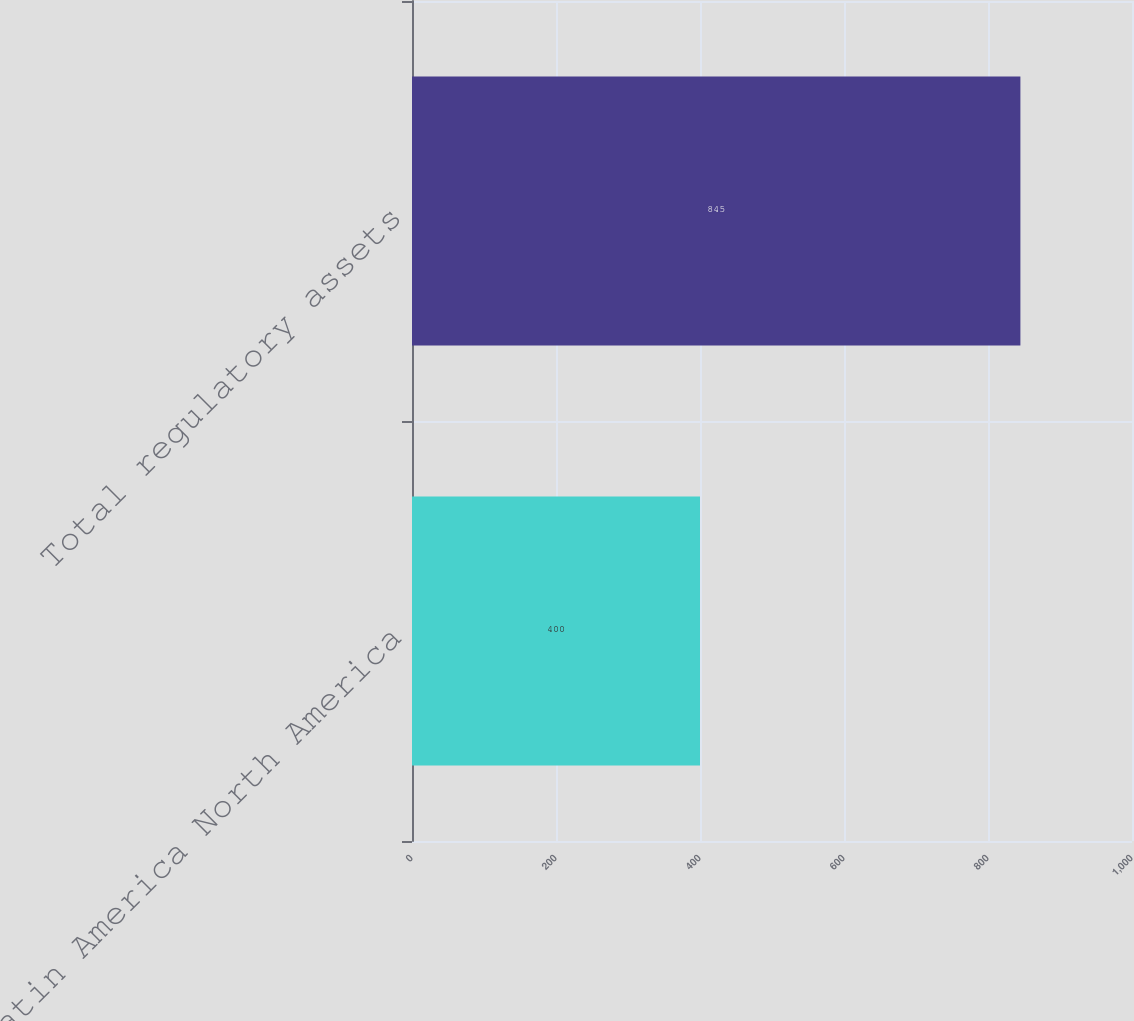Convert chart. <chart><loc_0><loc_0><loc_500><loc_500><bar_chart><fcel>Latin America North America<fcel>Total regulatory assets<nl><fcel>400<fcel>845<nl></chart> 